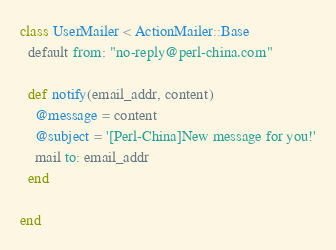Convert code to text. <code><loc_0><loc_0><loc_500><loc_500><_Ruby_>class UserMailer < ActionMailer::Base
  default from: "no-reply@perl-china.com"

  def notify(email_addr, content)
    @message = content
    @subject = '[Perl-China]New message for you!'
    mail to: email_addr
  end

end
</code> 